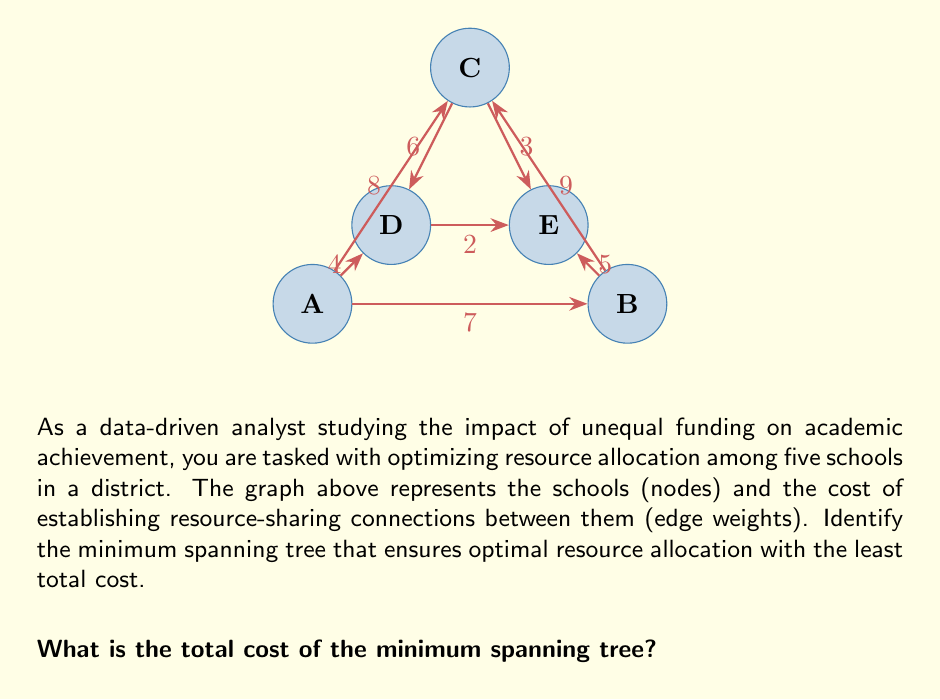Could you help me with this problem? To find the minimum spanning tree (MST) in this graph, we can use Kruskal's algorithm. This algorithm selects edges in order of increasing weight, adding each edge to the MST if it doesn't create a cycle. Here's the step-by-step process:

1) Sort the edges by weight in ascending order:
   D-E (2), C-E (3), A-D (4), B-E (5), C-D (6), A-B (7), A-C (8), B-C (9)

2) Start adding edges:
   - Add D-E (2)
   - Add C-E (3)
   - Add A-D (4)
   - Skip B-E (5) as it would create a cycle
   - Add C-D (6)

3) At this point, we have added 4 edges, which is sufficient for a minimum spanning tree in a graph with 5 nodes (n-1 edges where n is the number of nodes).

4) Calculate the total cost:
   $$\text{Total Cost} = 2 + 3 + 4 + 6 = 15$$

The minimum spanning tree consists of the edges D-E, C-E, A-D, and C-D, with a total cost of 15.
Answer: 15 